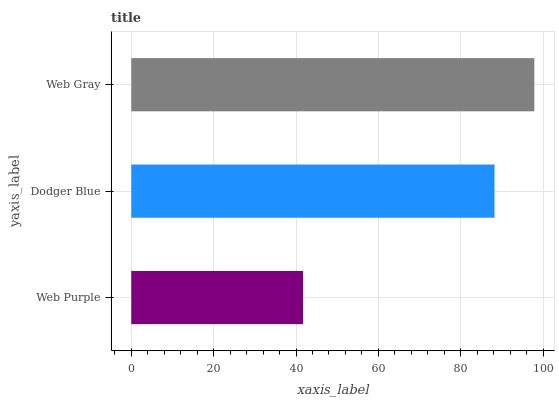Is Web Purple the minimum?
Answer yes or no. Yes. Is Web Gray the maximum?
Answer yes or no. Yes. Is Dodger Blue the minimum?
Answer yes or no. No. Is Dodger Blue the maximum?
Answer yes or no. No. Is Dodger Blue greater than Web Purple?
Answer yes or no. Yes. Is Web Purple less than Dodger Blue?
Answer yes or no. Yes. Is Web Purple greater than Dodger Blue?
Answer yes or no. No. Is Dodger Blue less than Web Purple?
Answer yes or no. No. Is Dodger Blue the high median?
Answer yes or no. Yes. Is Dodger Blue the low median?
Answer yes or no. Yes. Is Web Purple the high median?
Answer yes or no. No. Is Web Purple the low median?
Answer yes or no. No. 